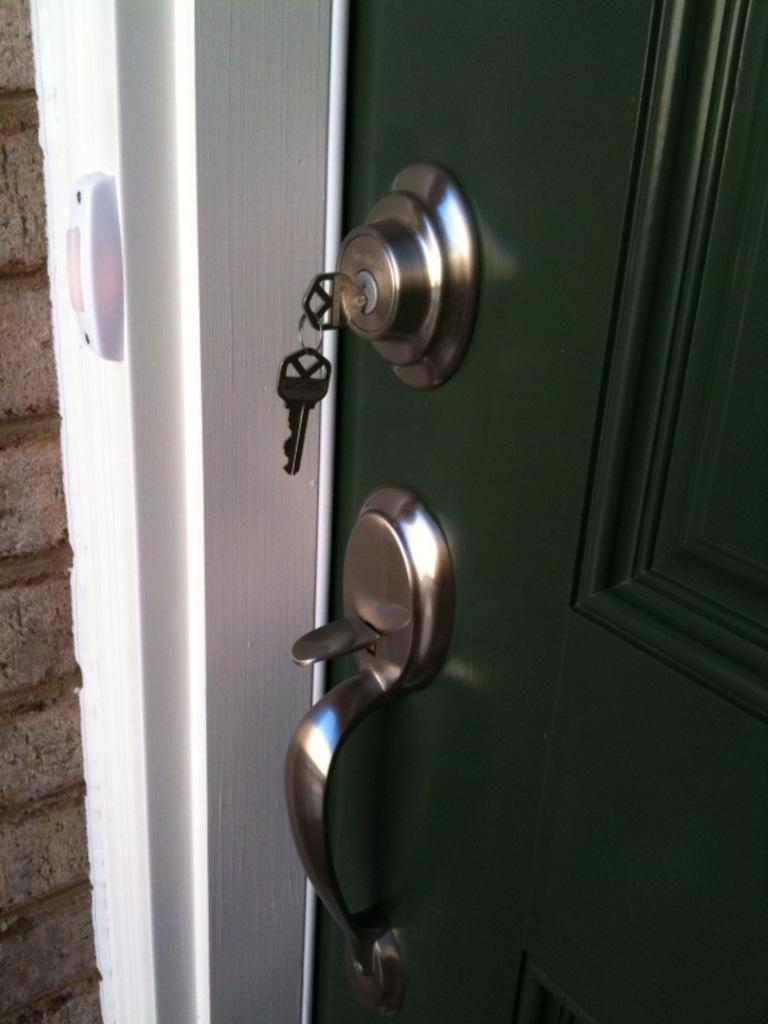What is present in the image that can be used for entering or exiting a room? There is a door in the image. What objects are related to the door in the image? There are couple keys in the image. Can you see a zebra taking a bath in the image? There is no zebra or bath present in the image. Is the uncle mentioned in the image? The image does not mention or depict an uncle. 